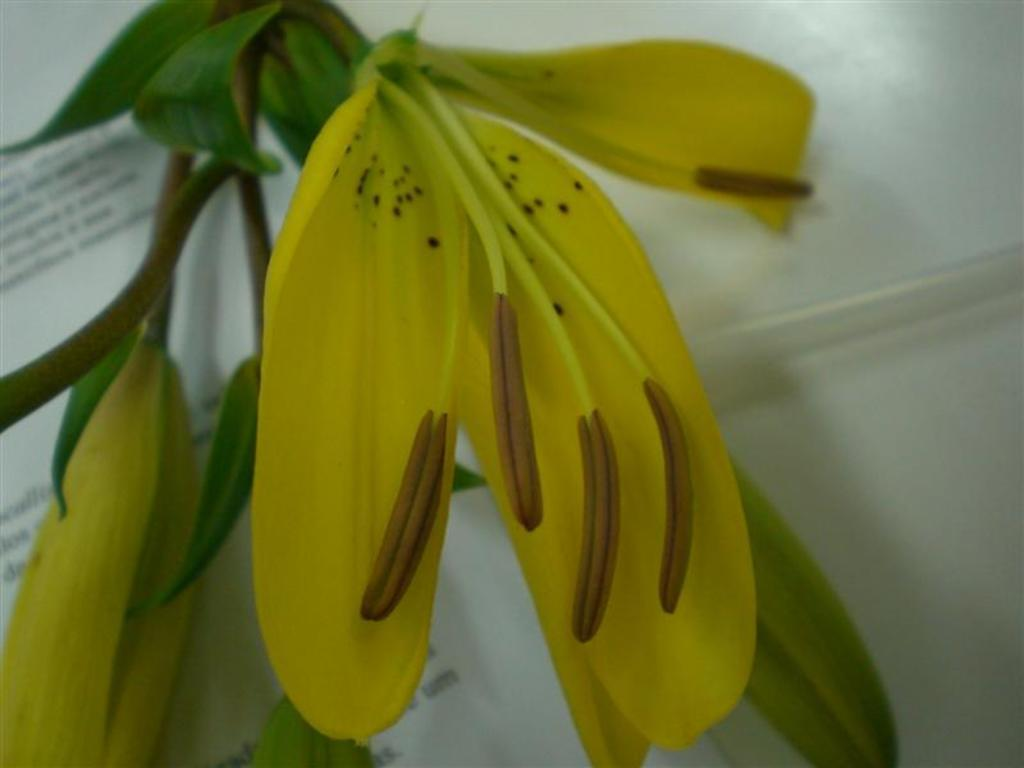What type of plant life can be seen in the image? There are flowers and leaves in the image. Where are the flowers and leaves located? They are likely part of a plant or arrangement in the image. What else is present on the table in the image? There is a paper on the table in the image. Can you see a beetle crawling on the paper in the image? There is no beetle present in the image. How many matches are visible on the table in the image? There is no mention of matches in the provided facts, so we cannot determine if any are present in the image. 